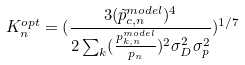<formula> <loc_0><loc_0><loc_500><loc_500>K _ { n } ^ { o p t } = ( \frac { 3 ( \tilde { p } _ { c , n } ^ { m o d e l } ) ^ { 4 } } { 2 \sum _ { k } ( \frac { p _ { k , n } ^ { m o d e l } } { p _ { n } } ) ^ { 2 } \sigma _ { D } ^ { 2 } \sigma _ { p } ^ { 2 } } ) ^ { 1 / 7 }</formula> 